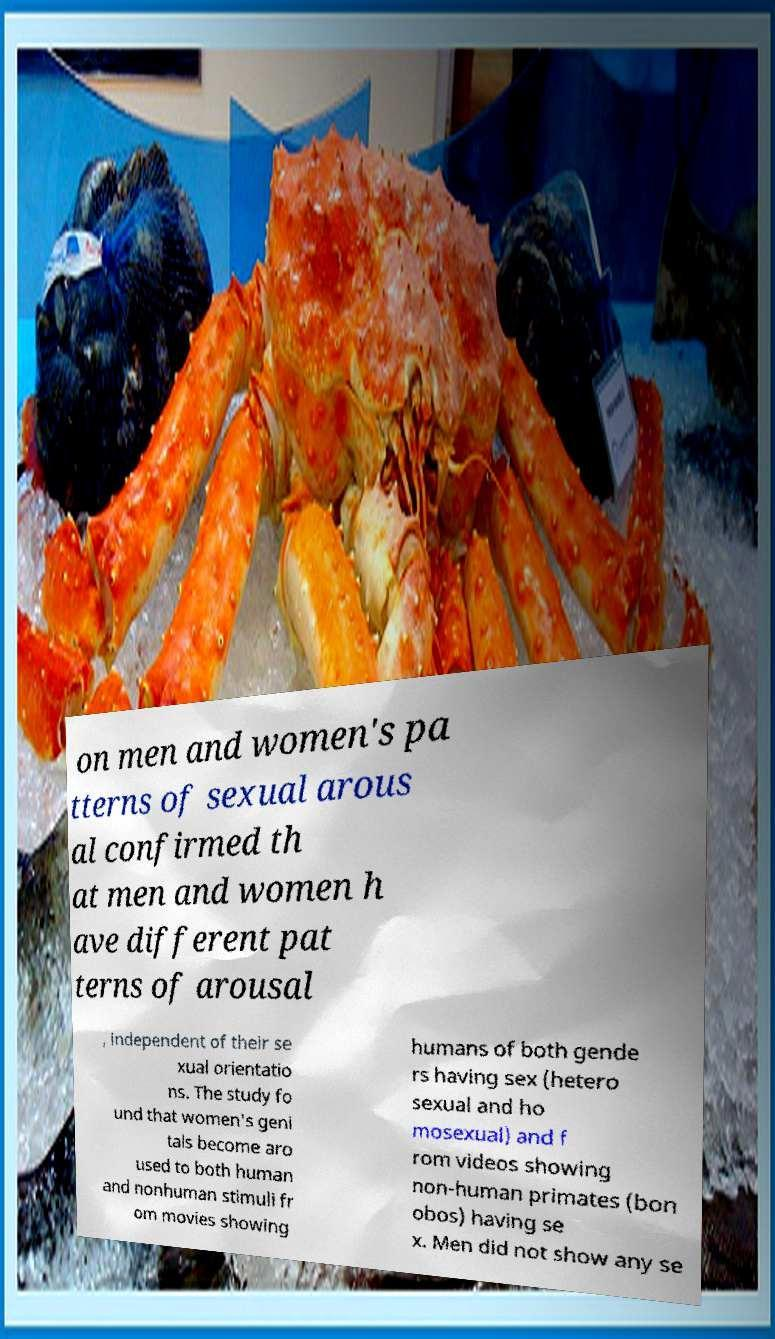Can you read and provide the text displayed in the image?This photo seems to have some interesting text. Can you extract and type it out for me? on men and women's pa tterns of sexual arous al confirmed th at men and women h ave different pat terns of arousal , independent of their se xual orientatio ns. The study fo und that women's geni tals become aro used to both human and nonhuman stimuli fr om movies showing humans of both gende rs having sex (hetero sexual and ho mosexual) and f rom videos showing non-human primates (bon obos) having se x. Men did not show any se 